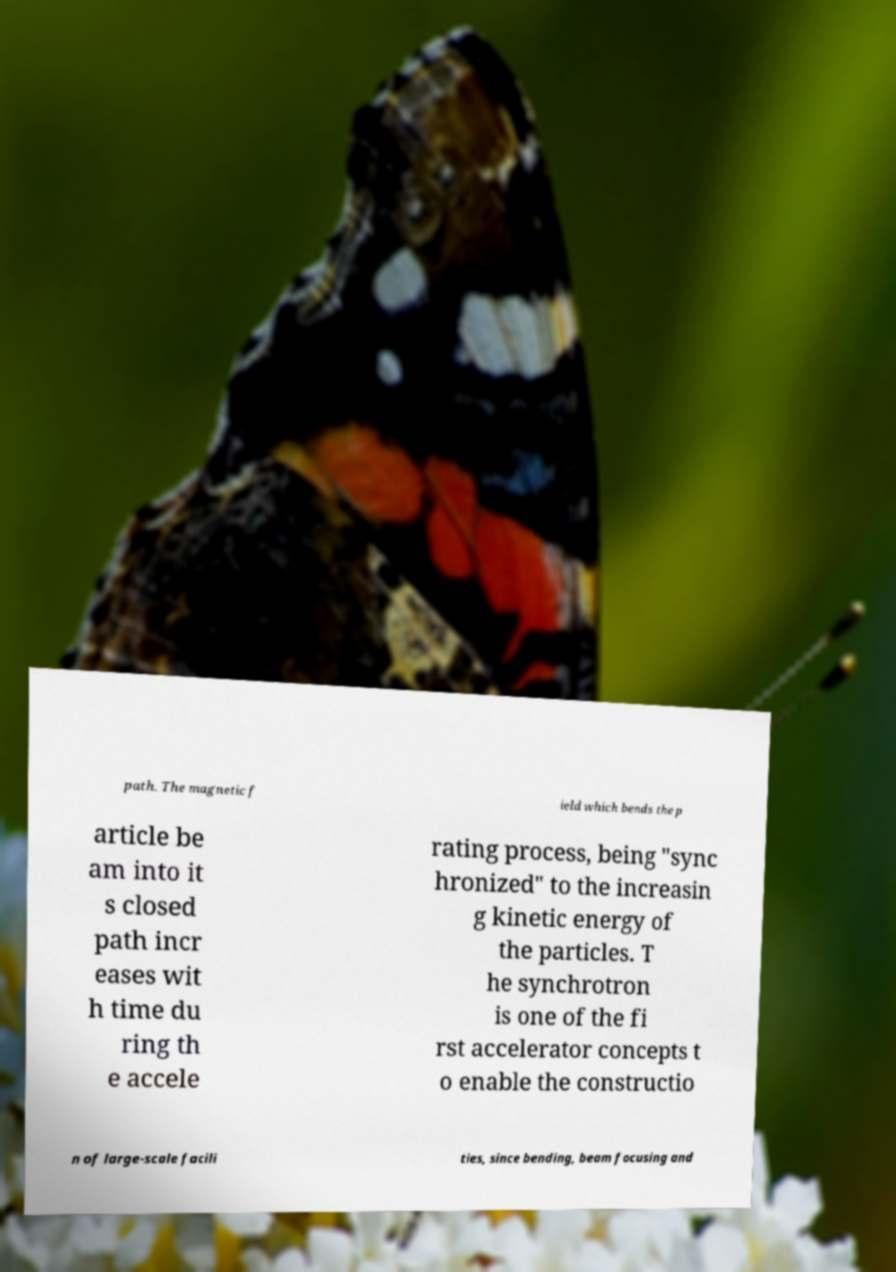There's text embedded in this image that I need extracted. Can you transcribe it verbatim? path. The magnetic f ield which bends the p article be am into it s closed path incr eases wit h time du ring th e accele rating process, being "sync hronized" to the increasin g kinetic energy of the particles. T he synchrotron is one of the fi rst accelerator concepts t o enable the constructio n of large-scale facili ties, since bending, beam focusing and 